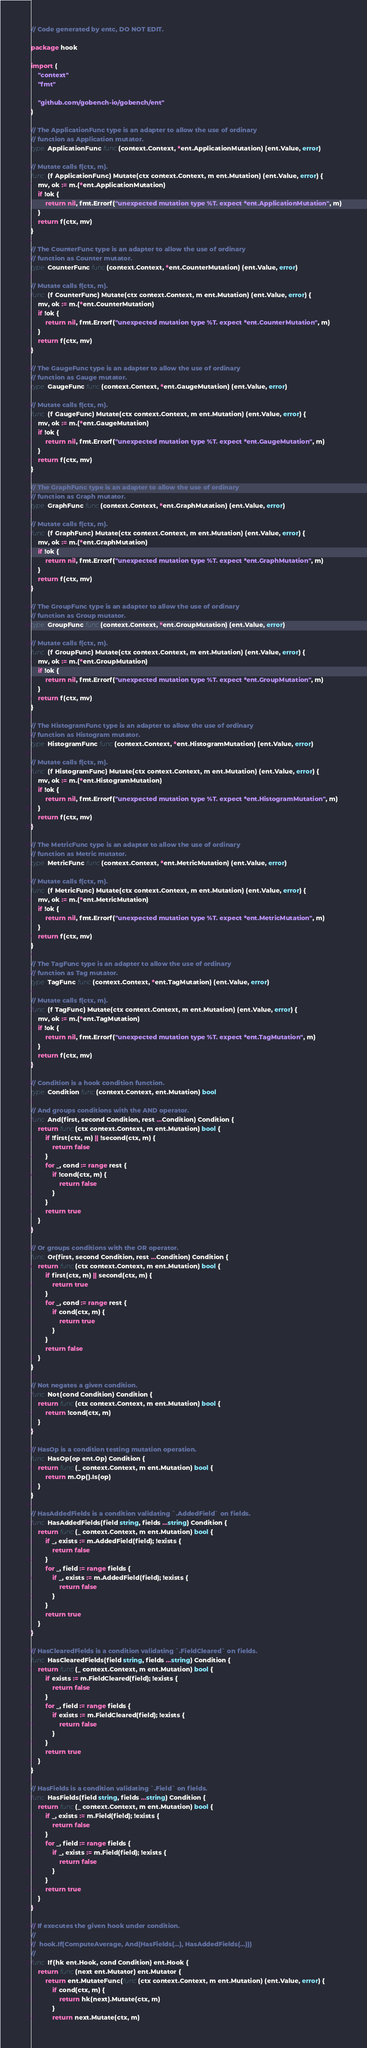Convert code to text. <code><loc_0><loc_0><loc_500><loc_500><_Go_>// Code generated by entc, DO NOT EDIT.

package hook

import (
	"context"
	"fmt"

	"github.com/gobench-io/gobench/ent"
)

// The ApplicationFunc type is an adapter to allow the use of ordinary
// function as Application mutator.
type ApplicationFunc func(context.Context, *ent.ApplicationMutation) (ent.Value, error)

// Mutate calls f(ctx, m).
func (f ApplicationFunc) Mutate(ctx context.Context, m ent.Mutation) (ent.Value, error) {
	mv, ok := m.(*ent.ApplicationMutation)
	if !ok {
		return nil, fmt.Errorf("unexpected mutation type %T. expect *ent.ApplicationMutation", m)
	}
	return f(ctx, mv)
}

// The CounterFunc type is an adapter to allow the use of ordinary
// function as Counter mutator.
type CounterFunc func(context.Context, *ent.CounterMutation) (ent.Value, error)

// Mutate calls f(ctx, m).
func (f CounterFunc) Mutate(ctx context.Context, m ent.Mutation) (ent.Value, error) {
	mv, ok := m.(*ent.CounterMutation)
	if !ok {
		return nil, fmt.Errorf("unexpected mutation type %T. expect *ent.CounterMutation", m)
	}
	return f(ctx, mv)
}

// The GaugeFunc type is an adapter to allow the use of ordinary
// function as Gauge mutator.
type GaugeFunc func(context.Context, *ent.GaugeMutation) (ent.Value, error)

// Mutate calls f(ctx, m).
func (f GaugeFunc) Mutate(ctx context.Context, m ent.Mutation) (ent.Value, error) {
	mv, ok := m.(*ent.GaugeMutation)
	if !ok {
		return nil, fmt.Errorf("unexpected mutation type %T. expect *ent.GaugeMutation", m)
	}
	return f(ctx, mv)
}

// The GraphFunc type is an adapter to allow the use of ordinary
// function as Graph mutator.
type GraphFunc func(context.Context, *ent.GraphMutation) (ent.Value, error)

// Mutate calls f(ctx, m).
func (f GraphFunc) Mutate(ctx context.Context, m ent.Mutation) (ent.Value, error) {
	mv, ok := m.(*ent.GraphMutation)
	if !ok {
		return nil, fmt.Errorf("unexpected mutation type %T. expect *ent.GraphMutation", m)
	}
	return f(ctx, mv)
}

// The GroupFunc type is an adapter to allow the use of ordinary
// function as Group mutator.
type GroupFunc func(context.Context, *ent.GroupMutation) (ent.Value, error)

// Mutate calls f(ctx, m).
func (f GroupFunc) Mutate(ctx context.Context, m ent.Mutation) (ent.Value, error) {
	mv, ok := m.(*ent.GroupMutation)
	if !ok {
		return nil, fmt.Errorf("unexpected mutation type %T. expect *ent.GroupMutation", m)
	}
	return f(ctx, mv)
}

// The HistogramFunc type is an adapter to allow the use of ordinary
// function as Histogram mutator.
type HistogramFunc func(context.Context, *ent.HistogramMutation) (ent.Value, error)

// Mutate calls f(ctx, m).
func (f HistogramFunc) Mutate(ctx context.Context, m ent.Mutation) (ent.Value, error) {
	mv, ok := m.(*ent.HistogramMutation)
	if !ok {
		return nil, fmt.Errorf("unexpected mutation type %T. expect *ent.HistogramMutation", m)
	}
	return f(ctx, mv)
}

// The MetricFunc type is an adapter to allow the use of ordinary
// function as Metric mutator.
type MetricFunc func(context.Context, *ent.MetricMutation) (ent.Value, error)

// Mutate calls f(ctx, m).
func (f MetricFunc) Mutate(ctx context.Context, m ent.Mutation) (ent.Value, error) {
	mv, ok := m.(*ent.MetricMutation)
	if !ok {
		return nil, fmt.Errorf("unexpected mutation type %T. expect *ent.MetricMutation", m)
	}
	return f(ctx, mv)
}

// The TagFunc type is an adapter to allow the use of ordinary
// function as Tag mutator.
type TagFunc func(context.Context, *ent.TagMutation) (ent.Value, error)

// Mutate calls f(ctx, m).
func (f TagFunc) Mutate(ctx context.Context, m ent.Mutation) (ent.Value, error) {
	mv, ok := m.(*ent.TagMutation)
	if !ok {
		return nil, fmt.Errorf("unexpected mutation type %T. expect *ent.TagMutation", m)
	}
	return f(ctx, mv)
}

// Condition is a hook condition function.
type Condition func(context.Context, ent.Mutation) bool

// And groups conditions with the AND operator.
func And(first, second Condition, rest ...Condition) Condition {
	return func(ctx context.Context, m ent.Mutation) bool {
		if !first(ctx, m) || !second(ctx, m) {
			return false
		}
		for _, cond := range rest {
			if !cond(ctx, m) {
				return false
			}
		}
		return true
	}
}

// Or groups conditions with the OR operator.
func Or(first, second Condition, rest ...Condition) Condition {
	return func(ctx context.Context, m ent.Mutation) bool {
		if first(ctx, m) || second(ctx, m) {
			return true
		}
		for _, cond := range rest {
			if cond(ctx, m) {
				return true
			}
		}
		return false
	}
}

// Not negates a given condition.
func Not(cond Condition) Condition {
	return func(ctx context.Context, m ent.Mutation) bool {
		return !cond(ctx, m)
	}
}

// HasOp is a condition testing mutation operation.
func HasOp(op ent.Op) Condition {
	return func(_ context.Context, m ent.Mutation) bool {
		return m.Op().Is(op)
	}
}

// HasAddedFields is a condition validating `.AddedField` on fields.
func HasAddedFields(field string, fields ...string) Condition {
	return func(_ context.Context, m ent.Mutation) bool {
		if _, exists := m.AddedField(field); !exists {
			return false
		}
		for _, field := range fields {
			if _, exists := m.AddedField(field); !exists {
				return false
			}
		}
		return true
	}
}

// HasClearedFields is a condition validating `.FieldCleared` on fields.
func HasClearedFields(field string, fields ...string) Condition {
	return func(_ context.Context, m ent.Mutation) bool {
		if exists := m.FieldCleared(field); !exists {
			return false
		}
		for _, field := range fields {
			if exists := m.FieldCleared(field); !exists {
				return false
			}
		}
		return true
	}
}

// HasFields is a condition validating `.Field` on fields.
func HasFields(field string, fields ...string) Condition {
	return func(_ context.Context, m ent.Mutation) bool {
		if _, exists := m.Field(field); !exists {
			return false
		}
		for _, field := range fields {
			if _, exists := m.Field(field); !exists {
				return false
			}
		}
		return true
	}
}

// If executes the given hook under condition.
//
//	hook.If(ComputeAverage, And(HasFields(...), HasAddedFields(...)))
//
func If(hk ent.Hook, cond Condition) ent.Hook {
	return func(next ent.Mutator) ent.Mutator {
		return ent.MutateFunc(func(ctx context.Context, m ent.Mutation) (ent.Value, error) {
			if cond(ctx, m) {
				return hk(next).Mutate(ctx, m)
			}
			return next.Mutate(ctx, m)</code> 